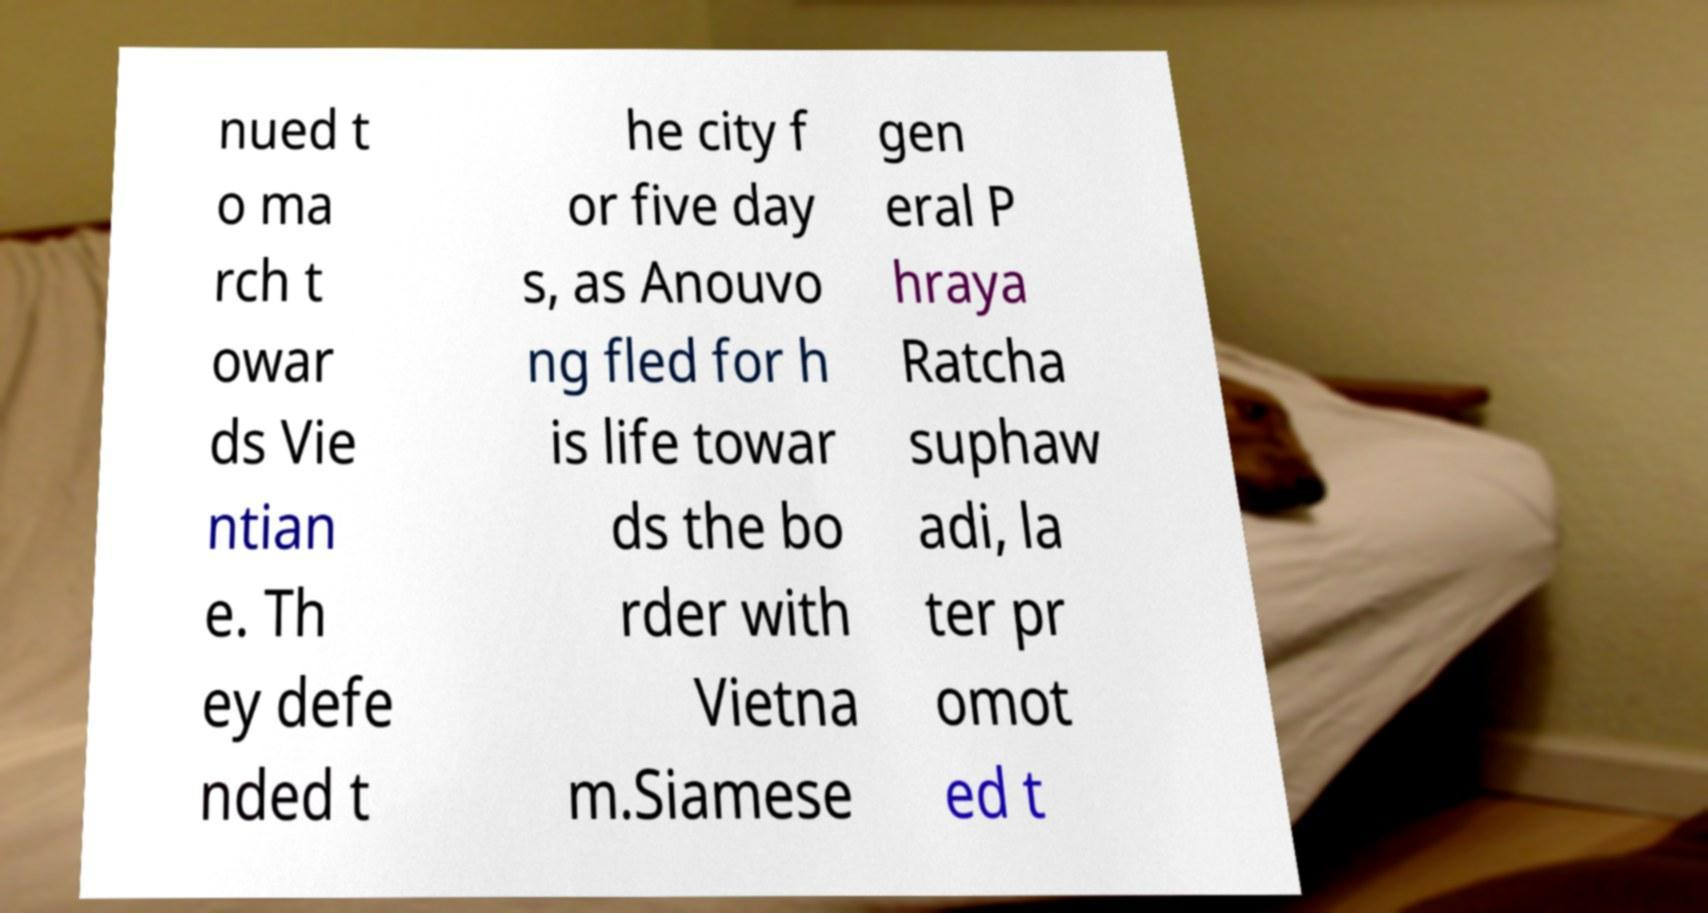Please identify and transcribe the text found in this image. nued t o ma rch t owar ds Vie ntian e. Th ey defe nded t he city f or five day s, as Anouvo ng fled for h is life towar ds the bo rder with Vietna m.Siamese gen eral P hraya Ratcha suphaw adi, la ter pr omot ed t 